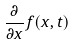Convert formula to latex. <formula><loc_0><loc_0><loc_500><loc_500>\frac { \partial } { \partial x } f ( x , t )</formula> 